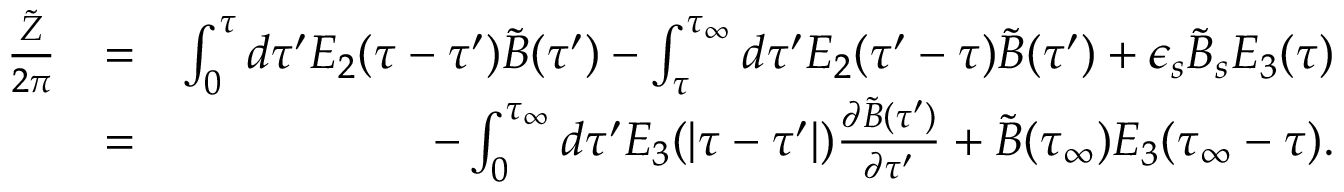Convert formula to latex. <formula><loc_0><loc_0><loc_500><loc_500>\begin{array} { r l r } { { \frac { \tilde { Z } } { 2 \pi } } } & { = } & { \int _ { 0 } ^ { \tau } d \tau ^ { \prime } E _ { 2 } ( \tau - \tau ^ { \prime } ) \tilde { B } ( \tau ^ { \prime } ) - \int _ { \tau } ^ { \tau _ { \infty } } d \tau ^ { \prime } E _ { 2 } ( \tau ^ { \prime } - \tau ) \tilde { B } ( \tau ^ { \prime } ) + \epsilon _ { s } \tilde { B } _ { s } E _ { 3 } ( \tau ) } \\ & { = } & { - \int _ { 0 } ^ { \tau _ { \infty } } d \tau ^ { \prime } E _ { 3 } ( | \tau - \tau ^ { \prime } | ) { \frac { \partial \tilde { B } ( \tau ^ { \prime } ) } { \partial \tau ^ { \prime } } } + \tilde { B } ( \tau _ { \infty } ) E _ { 3 } ( \tau _ { \infty } - \tau ) . } \end{array}</formula> 